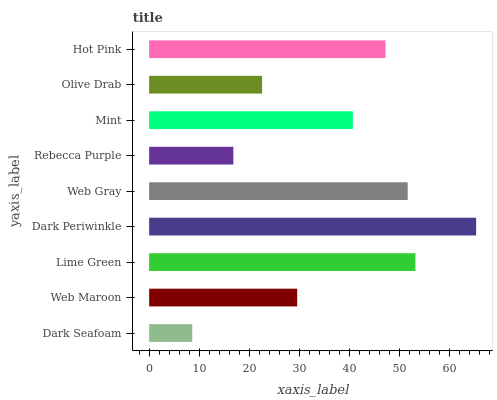Is Dark Seafoam the minimum?
Answer yes or no. Yes. Is Dark Periwinkle the maximum?
Answer yes or no. Yes. Is Web Maroon the minimum?
Answer yes or no. No. Is Web Maroon the maximum?
Answer yes or no. No. Is Web Maroon greater than Dark Seafoam?
Answer yes or no. Yes. Is Dark Seafoam less than Web Maroon?
Answer yes or no. Yes. Is Dark Seafoam greater than Web Maroon?
Answer yes or no. No. Is Web Maroon less than Dark Seafoam?
Answer yes or no. No. Is Mint the high median?
Answer yes or no. Yes. Is Mint the low median?
Answer yes or no. Yes. Is Web Gray the high median?
Answer yes or no. No. Is Rebecca Purple the low median?
Answer yes or no. No. 